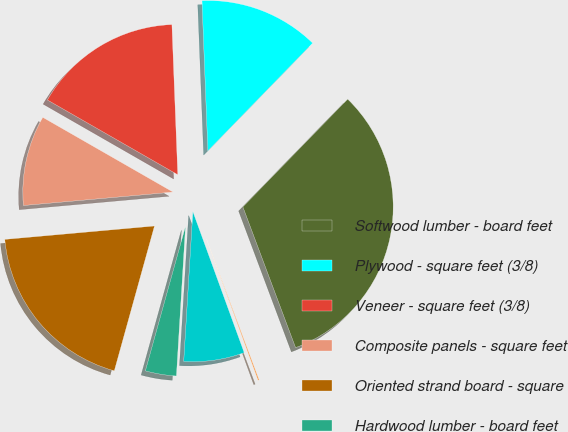<chart> <loc_0><loc_0><loc_500><loc_500><pie_chart><fcel>Softwood lumber - board feet<fcel>Plywood - square feet (3/8)<fcel>Veneer - square feet (3/8)<fcel>Composite panels - square feet<fcel>Oriented strand board - square<fcel>Hardwood lumber - board feet<fcel>Engineered I-Joists - lineal<fcel>Engineered solid section -<nl><fcel>32.02%<fcel>12.9%<fcel>16.09%<fcel>9.71%<fcel>19.27%<fcel>3.34%<fcel>6.52%<fcel>0.15%<nl></chart> 